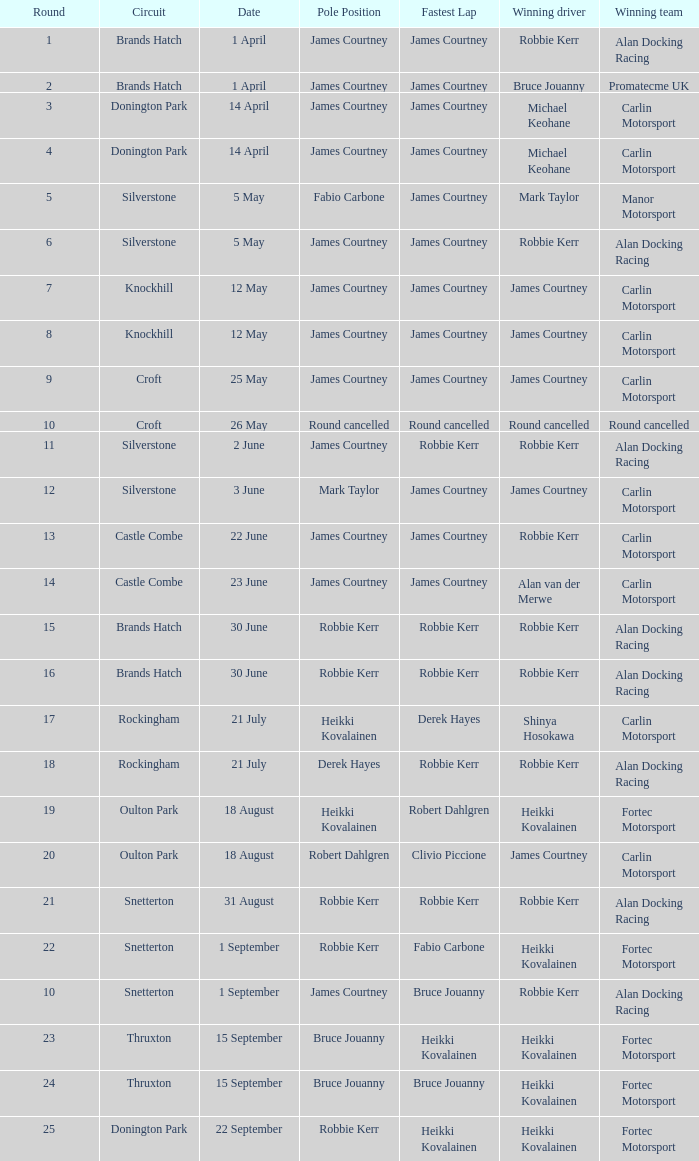What is every pole position for the Castle Combe circuit and Robbie Kerr is the winning driver? James Courtney. 